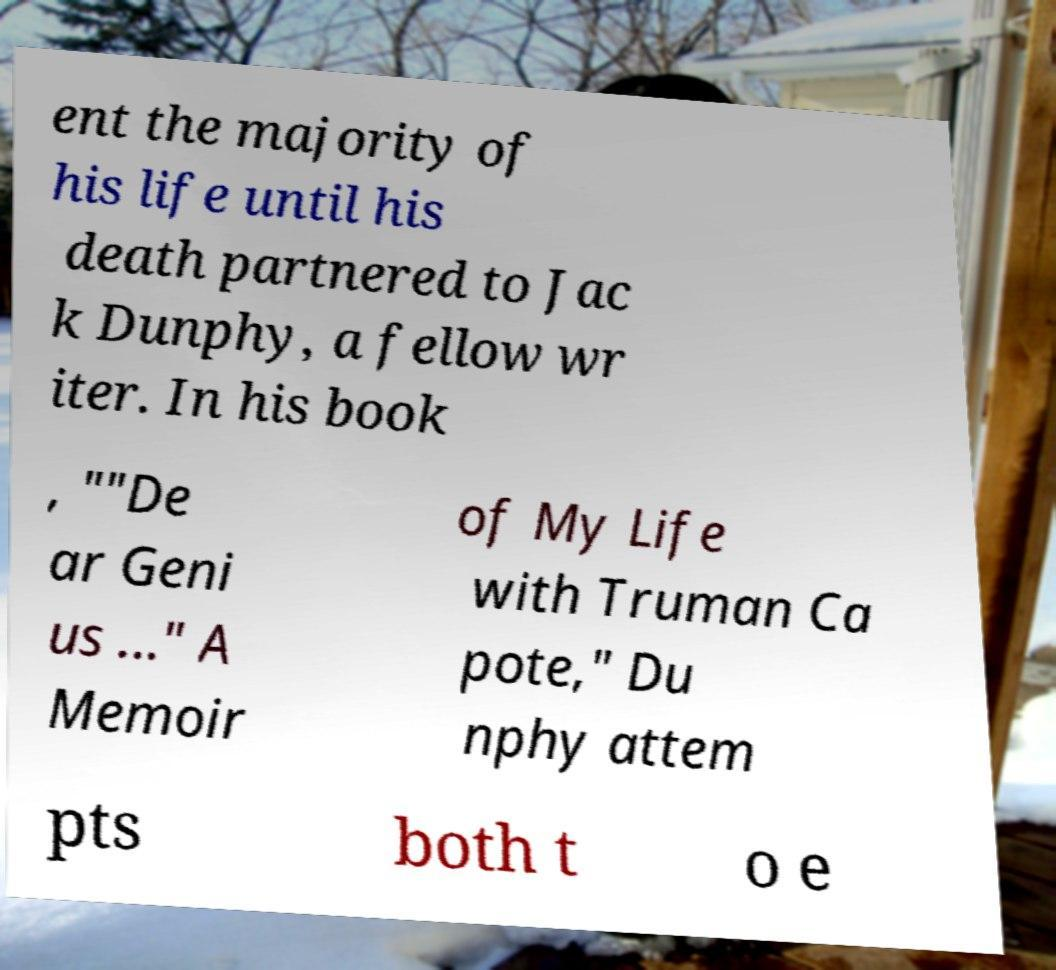Could you assist in decoding the text presented in this image and type it out clearly? ent the majority of his life until his death partnered to Jac k Dunphy, a fellow wr iter. In his book , ""De ar Geni us ..." A Memoir of My Life with Truman Ca pote," Du nphy attem pts both t o e 